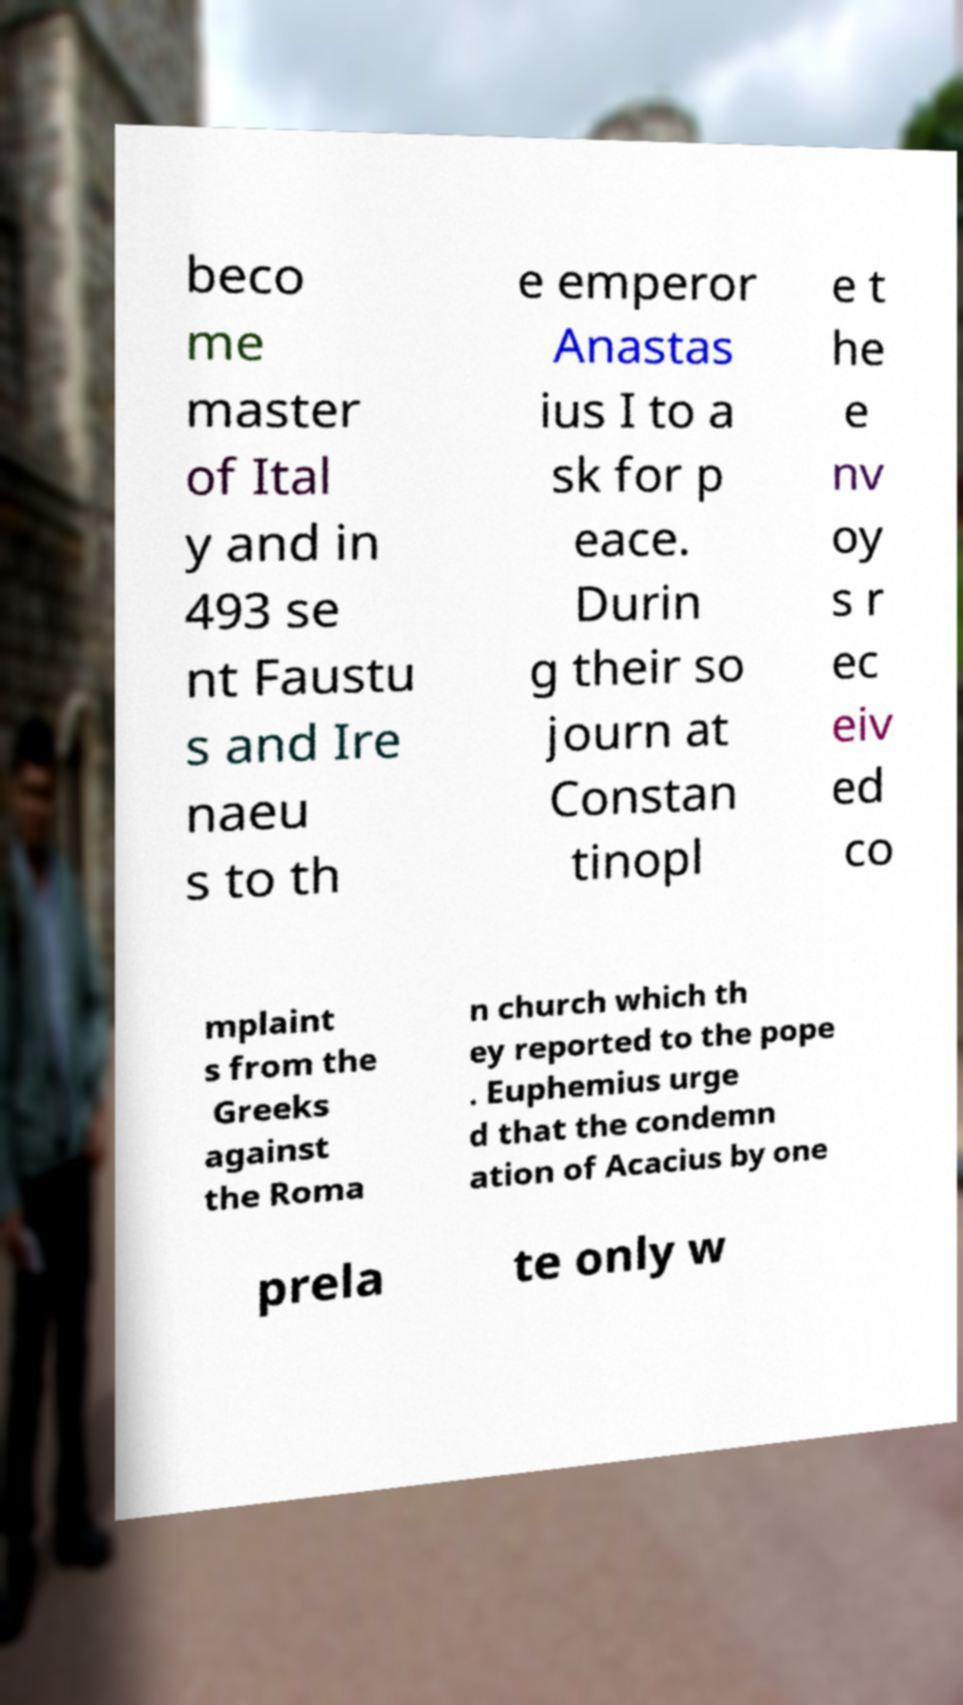Please identify and transcribe the text found in this image. beco me master of Ital y and in 493 se nt Faustu s and Ire naeu s to th e emperor Anastas ius I to a sk for p eace. Durin g their so journ at Constan tinopl e t he e nv oy s r ec eiv ed co mplaint s from the Greeks against the Roma n church which th ey reported to the pope . Euphemius urge d that the condemn ation of Acacius by one prela te only w 